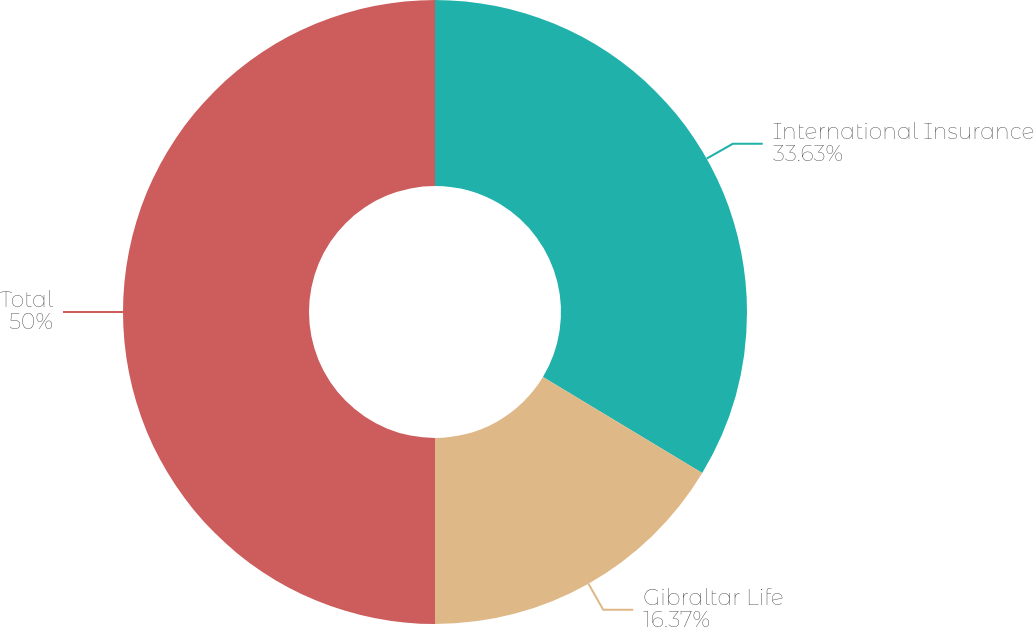Convert chart to OTSL. <chart><loc_0><loc_0><loc_500><loc_500><pie_chart><fcel>International Insurance<fcel>Gibraltar Life<fcel>Total<nl><fcel>33.63%<fcel>16.37%<fcel>50.0%<nl></chart> 